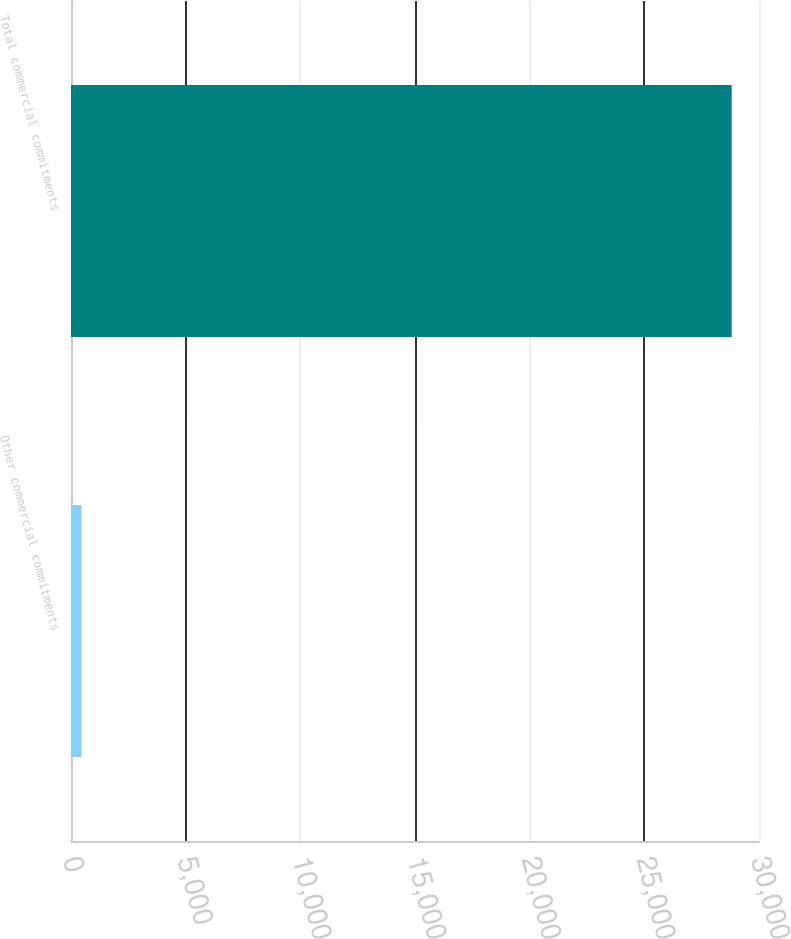Convert chart. <chart><loc_0><loc_0><loc_500><loc_500><bar_chart><fcel>Other commercial commitments<fcel>Total commercial commitments<nl><fcel>458<fcel>28809<nl></chart> 